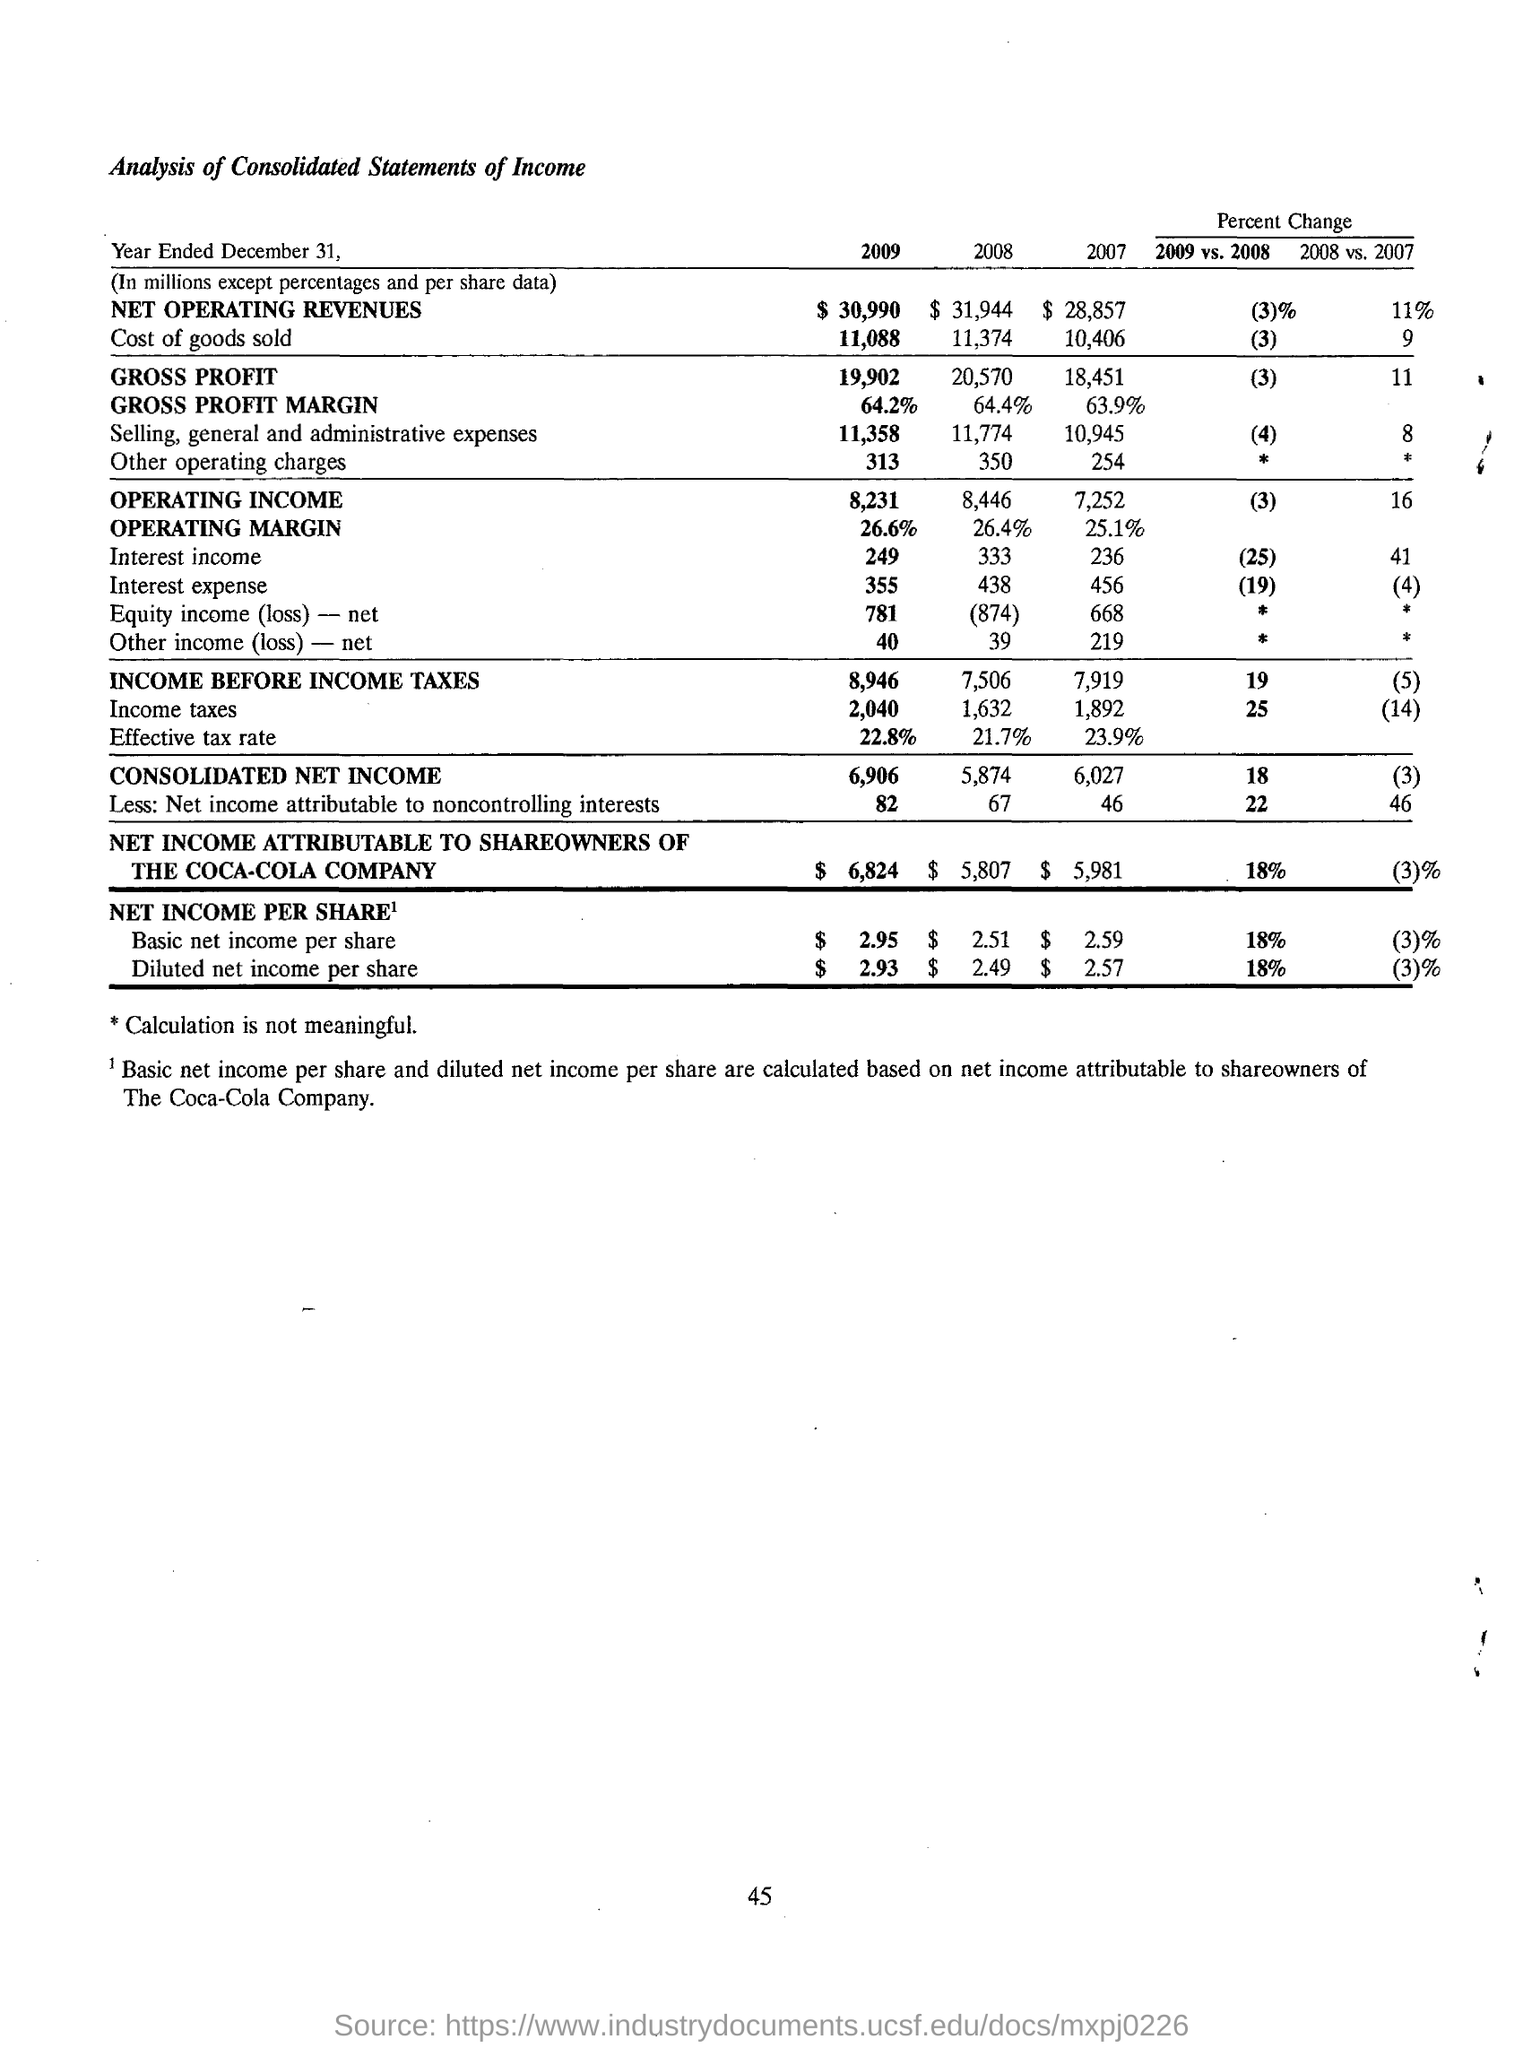What is the gross profit in the year 2009?
Ensure brevity in your answer.  19,902. What is the income before income tax for  the year 2007?
Give a very brief answer. 7,919. What is the basic net income per share for 2009 vs 2008
Your answer should be compact. 18%. What is the consolidated net income in the year 2008
Your answer should be compact. 5,874. What is the operating margin in the year 2009
Offer a very short reply. 26.6%. 